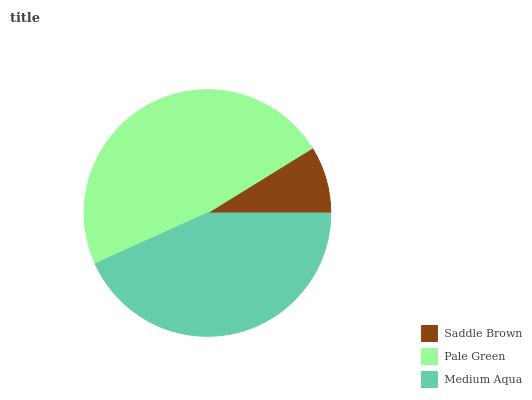Is Saddle Brown the minimum?
Answer yes or no. Yes. Is Pale Green the maximum?
Answer yes or no. Yes. Is Medium Aqua the minimum?
Answer yes or no. No. Is Medium Aqua the maximum?
Answer yes or no. No. Is Pale Green greater than Medium Aqua?
Answer yes or no. Yes. Is Medium Aqua less than Pale Green?
Answer yes or no. Yes. Is Medium Aqua greater than Pale Green?
Answer yes or no. No. Is Pale Green less than Medium Aqua?
Answer yes or no. No. Is Medium Aqua the high median?
Answer yes or no. Yes. Is Medium Aqua the low median?
Answer yes or no. Yes. Is Saddle Brown the high median?
Answer yes or no. No. Is Pale Green the low median?
Answer yes or no. No. 